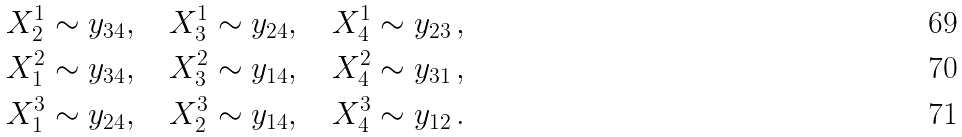<formula> <loc_0><loc_0><loc_500><loc_500>X ^ { 1 } _ { 2 } \sim y _ { 3 4 } , \quad X ^ { 1 } _ { 3 } \sim y _ { 2 4 } , \quad X ^ { 1 } _ { 4 } \sim y _ { 2 3 } \, , \\ X ^ { 2 } _ { 1 } \sim y _ { 3 4 } , \quad X ^ { 2 } _ { 3 } \sim y _ { 1 4 } , \quad X ^ { 2 } _ { 4 } \sim y _ { 3 1 } \, , \\ X ^ { 3 } _ { 1 } \sim y _ { 2 4 } , \quad X ^ { 3 } _ { 2 } \sim y _ { 1 4 } , \quad X ^ { 3 } _ { 4 } \sim y _ { 1 2 } \, .</formula> 